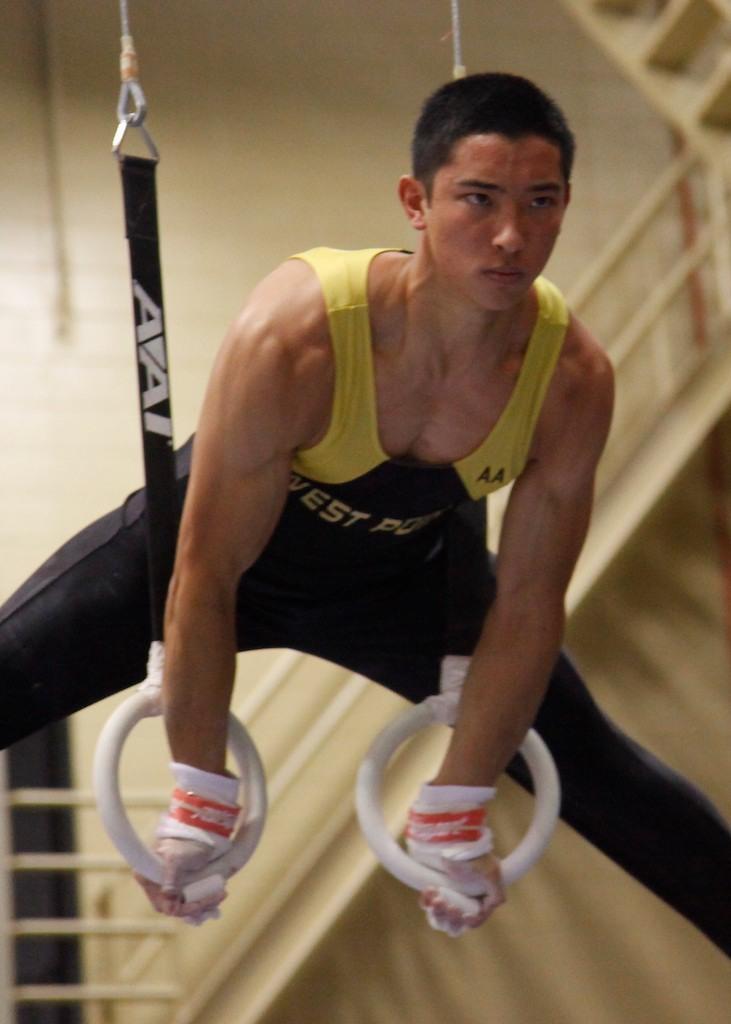Please provide a concise description of this image. There is a man performing gymnastics with rings. In the back there is a railing. 